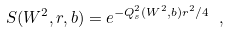<formula> <loc_0><loc_0><loc_500><loc_500>S ( W ^ { 2 } , r , b ) = e ^ { - Q _ { s } ^ { 2 } ( W ^ { 2 } , b ) r ^ { 2 } / 4 } \ ,</formula> 